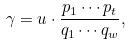Convert formula to latex. <formula><loc_0><loc_0><loc_500><loc_500>\gamma = u \cdot \frac { p _ { 1 } \cdots p _ { t } } { q _ { 1 } \cdots q _ { w } } ,</formula> 